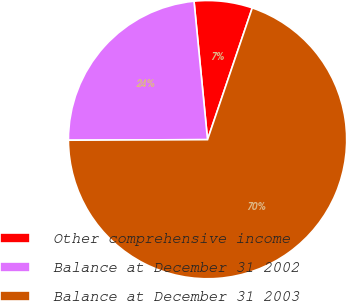<chart> <loc_0><loc_0><loc_500><loc_500><pie_chart><fcel>Other comprehensive income<fcel>Balance at December 31 2002<fcel>Balance at December 31 2003<nl><fcel>6.76%<fcel>23.51%<fcel>69.73%<nl></chart> 